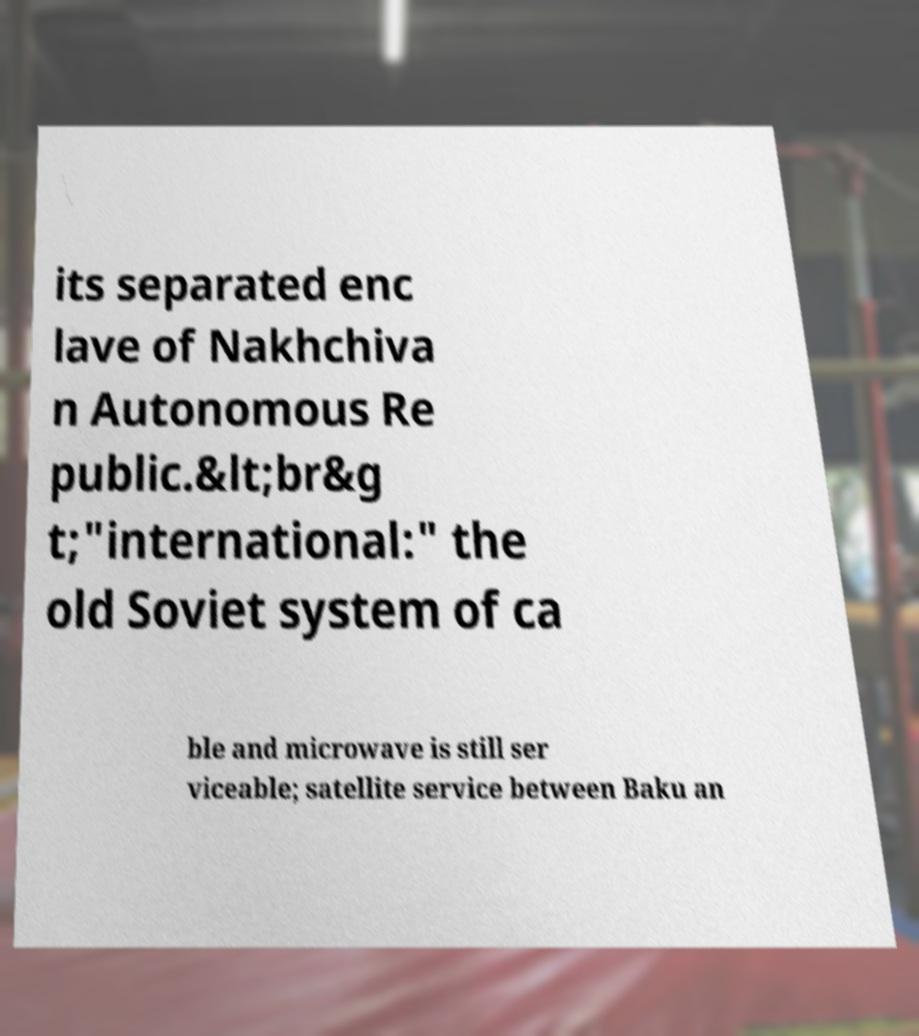There's text embedded in this image that I need extracted. Can you transcribe it verbatim? its separated enc lave of Nakhchiva n Autonomous Re public.&lt;br&g t;"international:" the old Soviet system of ca ble and microwave is still ser viceable; satellite service between Baku an 